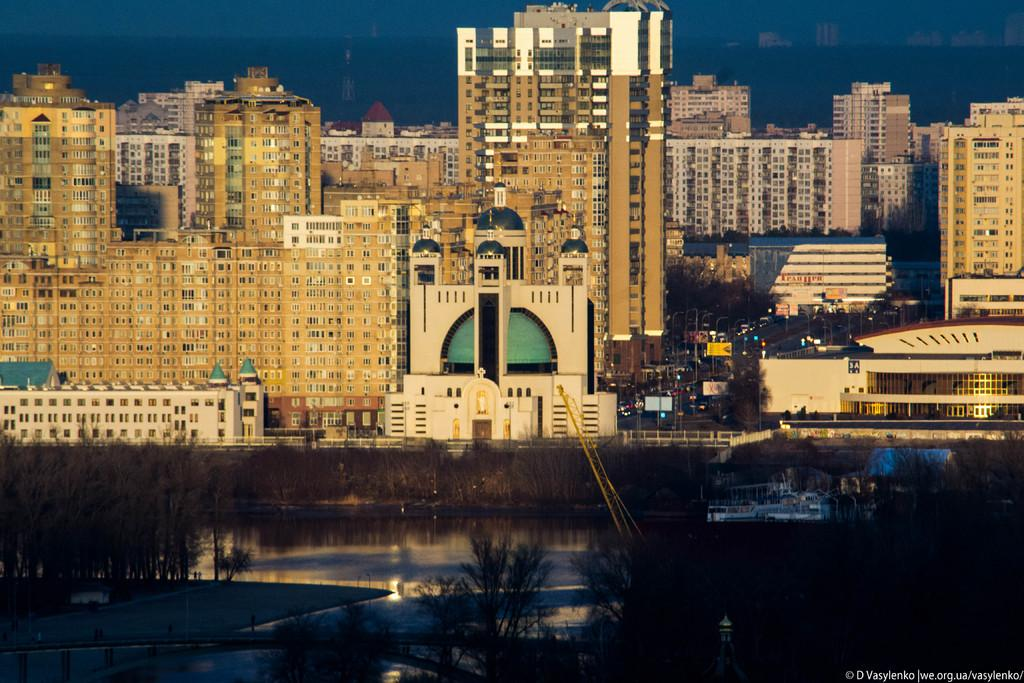What is located in the front of the image? There are trees in the front of the image. What is in the center of the image? There is water in the center of the image. What can be seen in the background of the image? There are buildings, vehicles, poles, and trees in the background of the image. What type of box is being carried by the donkey in the image? There is no donkey or box present in the image. What nation is depicted in the image? The image does not depict a specific nation; it shows a scene with trees, water, buildings, vehicles, poles, and trees in the background. 